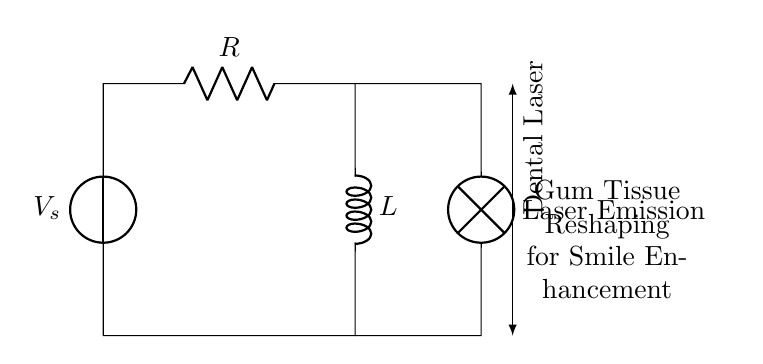What is the voltage source in this circuit? The voltage source is denoted by $V_s$, which provides the electrical potential required for the operation of the circuit.
Answer: V_s What is the role of the resistor in this circuit? The resistor, labeled $R$, limits the amount of current that can flow through the circuit, thereby helping to control the energy supplied to the load, which in this case is the dental laser.
Answer: Current limiting What is the inductance component in this circuit? The inductor is represented by the label $L$, which stores energy in a magnetic field when current flows through it.
Answer: L What component is responsible for laser emission? The component responsible for laser emission is labeled as "Dental Laser" in the circuit diagram, indicating the purpose of the circuit in relation to cosmetic procedures.
Answer: Dental Laser How does energy flow in this RL circuit? Energy flows from the voltage source through the resistor and inductor before reaching the dental laser, where it is used for emitting laser light for gum tissue reshaping.
Answer: In a loop What happens to the current when the circuit is first energized? When the circuit is first energized, the current through the inductor initially rises slowly due to its opposition to changes in current, which is a characteristic behavior of inductors.
Answer: Slow rise What is the purpose of the inductor in conjunction with the resistor? The inductor in conjunction with the resistor creates a time-dependent current, allowing for smooth current flow and reducing sudden changes, which is crucial for stable laser operation.
Answer: Smooth current flow 